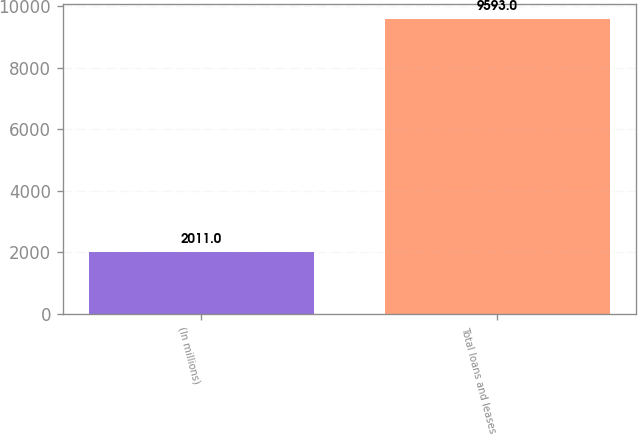<chart> <loc_0><loc_0><loc_500><loc_500><bar_chart><fcel>(In millions)<fcel>Total loans and leases<nl><fcel>2011<fcel>9593<nl></chart> 